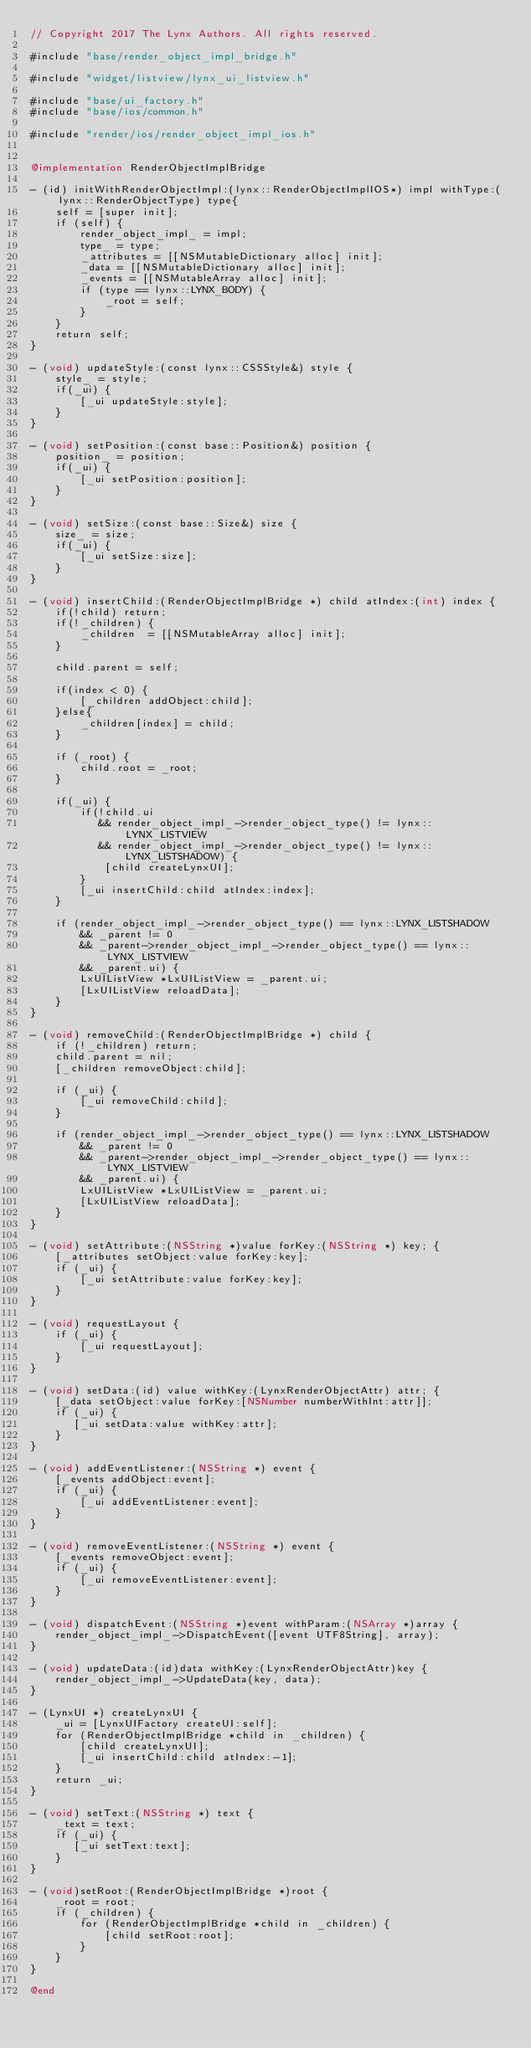<code> <loc_0><loc_0><loc_500><loc_500><_ObjectiveC_>// Copyright 2017 The Lynx Authors. All rights reserved.

#include "base/render_object_impl_bridge.h"

#include "widget/listview/lynx_ui_listview.h"

#include "base/ui_factory.h"
#include "base/ios/common.h"

#include "render/ios/render_object_impl_ios.h"


@implementation RenderObjectImplBridge

- (id) initWithRenderObjectImpl:(lynx::RenderObjectImplIOS*) impl withType:(lynx::RenderObjectType) type{
    self = [super init];
    if (self) {
        render_object_impl_ = impl;
        type_ = type;
        _attributes = [[NSMutableDictionary alloc] init];
        _data = [[NSMutableDictionary alloc] init];
        _events = [[NSMutableArray alloc] init];
        if (type == lynx::LYNX_BODY) {
            _root = self;
        }
    }
    return self;
}

- (void) updateStyle:(const lynx::CSSStyle&) style {
    style_ = style;
    if(_ui) {
        [_ui updateStyle:style];
    }
}

- (void) setPosition:(const base::Position&) position {
    position_ = position;
    if(_ui) {
        [_ui setPosition:position];
    }
}

- (void) setSize:(const base::Size&) size {
    size_ = size;
    if(_ui) {
        [_ui setSize:size];
    }
}

- (void) insertChild:(RenderObjectImplBridge *) child atIndex:(int) index {
    if(!child) return;
    if(!_children) {
        _children  = [[NSMutableArray alloc] init];
    }
    
    child.parent = self;
    
    if(index < 0) {
        [_children addObject:child];
    }else{
        _children[index] = child;
    }
    
    if (_root) {
        child.root = _root;
    }
    
    if(_ui) {
        if(!child.ui
           && render_object_impl_->render_object_type() != lynx::LYNX_LISTVIEW
           && render_object_impl_->render_object_type() != lynx::LYNX_LISTSHADOW) {
            [child createLynxUI];
        }
        [_ui insertChild:child atIndex:index];
    }
    
    if (render_object_impl_->render_object_type() == lynx::LYNX_LISTSHADOW
        && _parent != 0
        && _parent->render_object_impl_->render_object_type() == lynx::LYNX_LISTVIEW
        && _parent.ui) {
        LxUIListView *LxUIListView = _parent.ui;
        [LxUIListView reloadData];
    }
}

- (void) removeChild:(RenderObjectImplBridge *) child {
    if (!_children) return;
    child.parent = nil;
    [_children removeObject:child];
    
    if (_ui) {
        [_ui removeChild:child];
    }
    
    if (render_object_impl_->render_object_type() == lynx::LYNX_LISTSHADOW
        && _parent != 0
        && _parent->render_object_impl_->render_object_type() == lynx::LYNX_LISTVIEW
        && _parent.ui) {
        LxUIListView *LxUIListView = _parent.ui;
        [LxUIListView reloadData];
    }
}

- (void) setAttribute:(NSString *)value forKey:(NSString *) key; {
    [_attributes setObject:value forKey:key];
    if (_ui) {
        [_ui setAttribute:value forKey:key];
    }
}

- (void) requestLayout {
    if (_ui) {
        [_ui requestLayout];
    }
}

- (void) setData:(id) value withKey:(LynxRenderObjectAttr) attr; {
    [_data setObject:value forKey:[NSNumber numberWithInt:attr]];
    if (_ui) {
       [_ui setData:value withKey:attr];
    }
}

- (void) addEventListener:(NSString *) event {
    [_events addObject:event];
    if (_ui) {
        [_ui addEventListener:event];
    }
}

- (void) removeEventListener:(NSString *) event {
    [_events removeObject:event];
    if (_ui) {
        [_ui removeEventListener:event];
    }
}

- (void) dispatchEvent:(NSString *)event withParam:(NSArray *)array {
    render_object_impl_->DispatchEvent([event UTF8String], array);
}

- (void) updateData:(id)data withKey:(LynxRenderObjectAttr)key {
    render_object_impl_->UpdateData(key, data);
}

- (LynxUI *) createLynxUI {
    _ui = [LynxUIFactory createUI:self];
    for (RenderObjectImplBridge *child in _children) {
        [child createLynxUI];
        [_ui insertChild:child atIndex:-1];
    }
    return _ui;
}

- (void) setText:(NSString *) text {
    _text = text;
    if (_ui) {
       [_ui setText:text];
    }
}

- (void)setRoot:(RenderObjectImplBridge *)root {
    _root = root;
    if (_children) {
        for (RenderObjectImplBridge *child in _children) {
            [child setRoot:root];
        }
    }
}

@end
</code> 